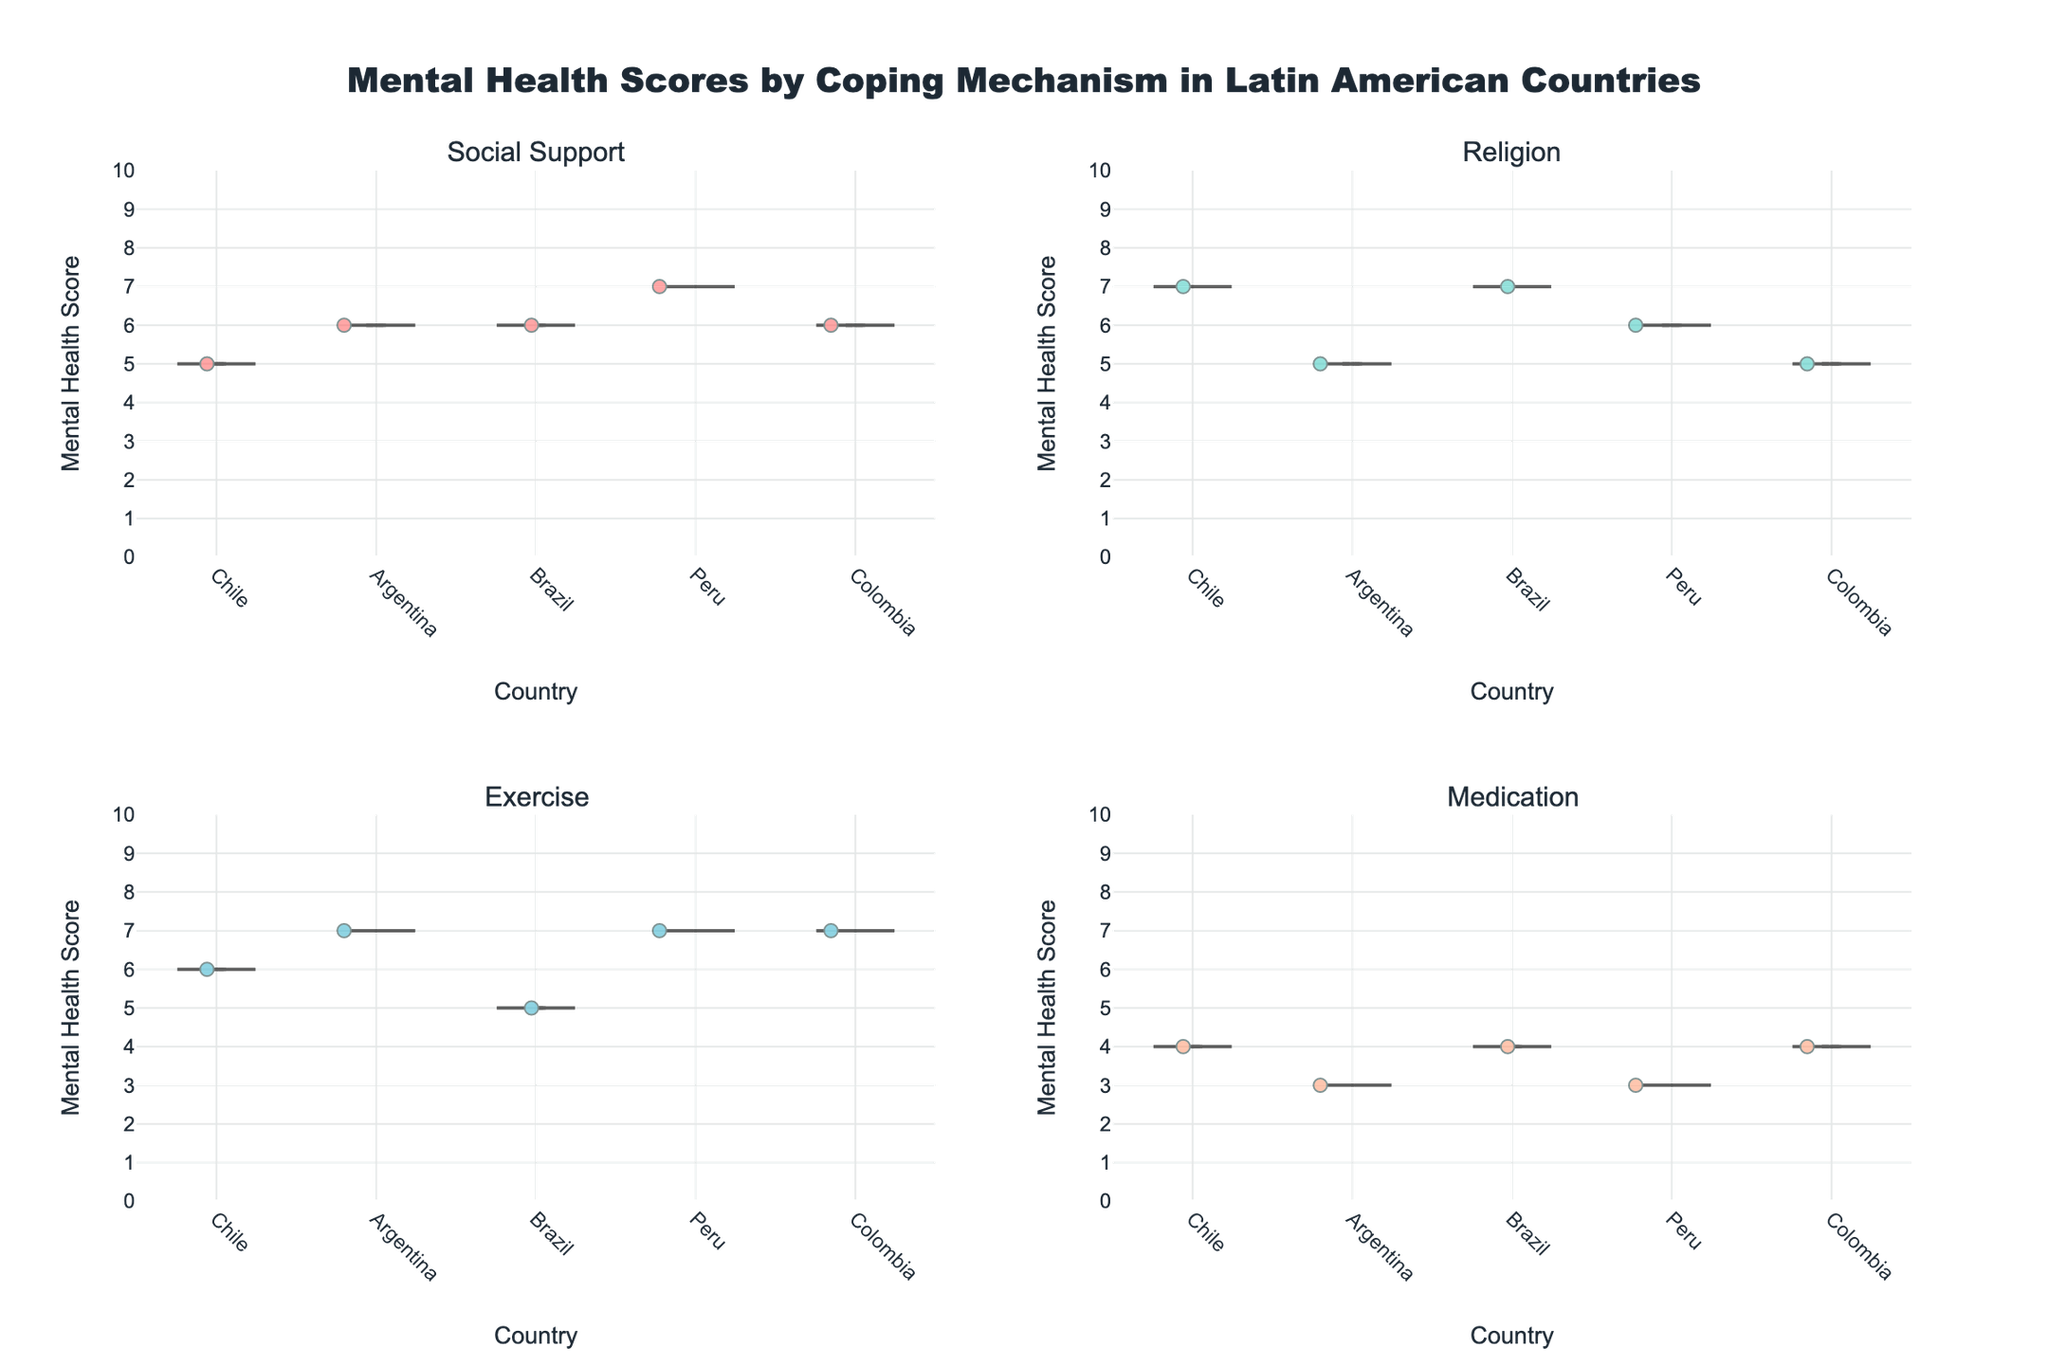What are the four coping mechanisms shown in the figure? The figure has subplots titled "Social Support", "Religion", "Exercise", and "Medication", which represent the four coping mechanisms.
Answer: Social Support, Religion, Exercise, Medication Which country has the highest median mental health score for the coping mechanism "Social Support"? For "Social Support", the median mental health scores can be compared across countries. The median line shows that Peru has the highest median mental health score.
Answer: Peru What is the range of mental health scores for the "Medication" coping mechanism in Brazil? The "Medication" subplot for Brazil shows data points between the scores of 3 and 4, indicating the range.
Answer: 3 to 4 Which country shows the most variation in mental health scores for the "Exercise" coping mechanism? In the "Exercise" subplot, Colombia displays the widest spread of data points, indicating the most variation.
Answer: Colombia What is the average mental health score for all countries using the "Religion" coping mechanism? For "Religion", the mental health scores are 7, 5, 7, 6, and 5 across Chile, Argentina, Brazil, Peru, and Colombia. The average is (7 + 5 + 7 + 6 + 5) / 5 = 6.
Answer: 6 How do the mental health scores for "Social Support" in Chile compare with those in Argentina? "Social Support" in Chile has lower data points compared to Argentina, indicating that Argentina has slightly higher mental health scores overall.
Answer: Argentina is higher What is the lowest mental health score observed across all coping mechanisms? The lowest mental health score data point observed across all subplots is 3, visible in the "Medication" subplot for Argentina and Peru.
Answer: 3 Which coping mechanism has the highest overall mental health scores? Based on the visual distribution of data points, "Exercise" has the highest overall mental health scores across all countries.
Answer: Exercise Are there any outliers in the "Religion" coping mechanism subplot for any country? In the "Religion" subplot, the data points are closely packed, and no data point is separate from the bulk, indicating no outliers.
Answer: No Which coping mechanism shows the smallest median mental health score? By comparing the median lines, "Medication" has the smallest median mental health score across the coping mechanisms.
Answer: Medication 